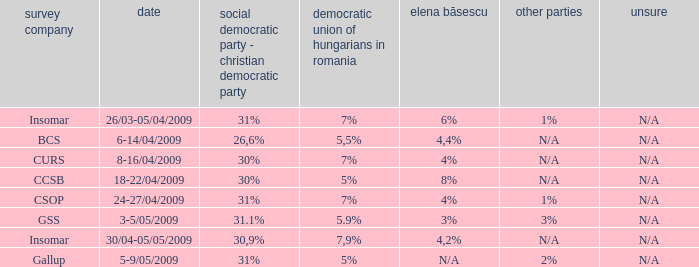What date has the others of 2%? 5-9/05/2009. 